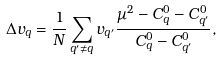Convert formula to latex. <formula><loc_0><loc_0><loc_500><loc_500>\Delta { v } _ { q } = \frac { 1 } { N } \sum _ { { q } ^ { \prime } \neq { q } } { v } _ { { q } ^ { \prime } } \frac { \mu ^ { 2 } - C ^ { 0 } _ { q } - C ^ { 0 } _ { { q } ^ { \prime } } } { C ^ { 0 } _ { q } - C ^ { 0 } _ { { q } ^ { \prime } } } ,</formula> 